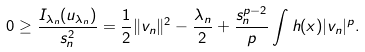<formula> <loc_0><loc_0><loc_500><loc_500>0 \geq \frac { I _ { \lambda _ { n } } ( u _ { \lambda _ { n } } ) } { s _ { n } ^ { 2 } } = \frac { 1 } { 2 } \| v _ { n } \| ^ { 2 } - \frac { \lambda _ { n } } { 2 } + \frac { s _ { n } ^ { p - 2 } } { p } \int h ( x ) | v _ { n } | ^ { p } .</formula> 